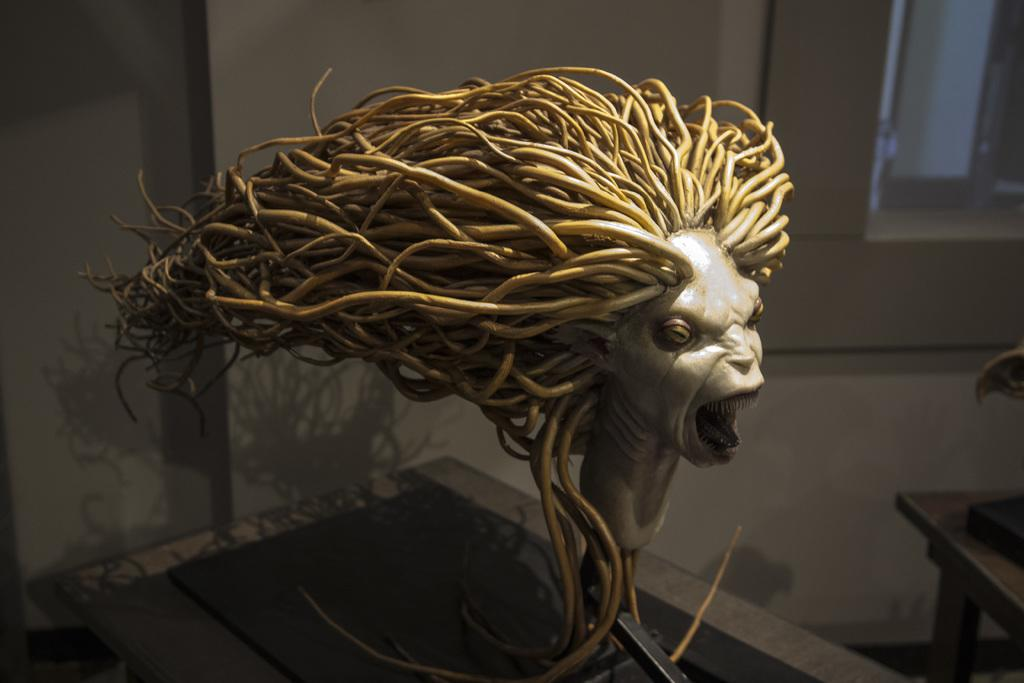What is the main subject of the image? There is an idol in the image. Can you describe the appearance of the idol? The idol has long hairs. How are the long hairs arranged? The long hairs are arranged in a vertical line. What type of vacation is the idol planning in the image? There is no indication of a vacation or any planning in the image; it features an idol with long hairs arranged in a vertical line. 